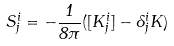Convert formula to latex. <formula><loc_0><loc_0><loc_500><loc_500>S _ { j } ^ { i } = - \frac { 1 } { 8 \pi } ( [ K _ { j } ^ { i } ] - \delta _ { j } ^ { i } K )</formula> 